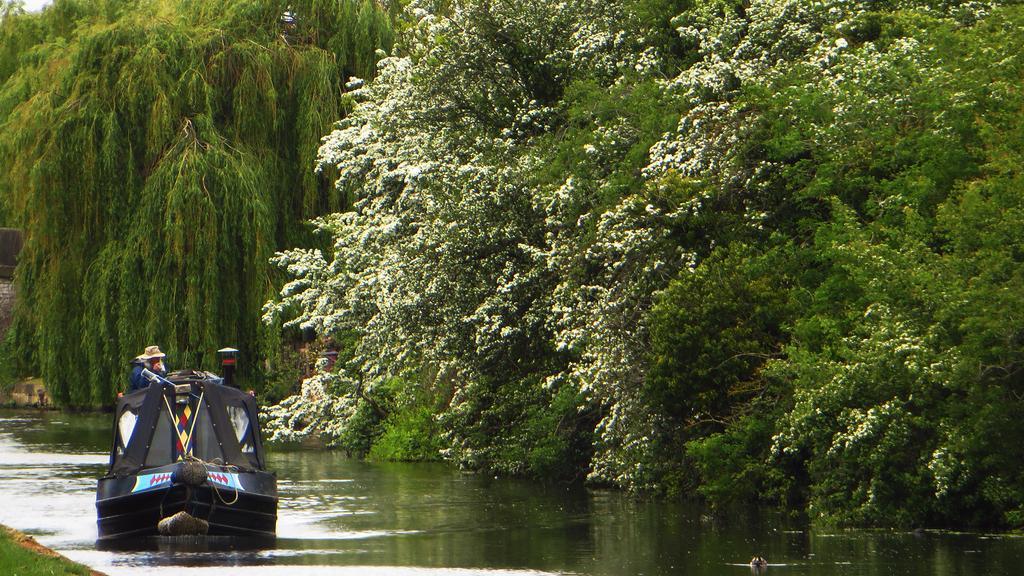Describe this image in one or two sentences. In this image I see number of trees and I see the green grass over here and I see the black boat on which there is a person and I see the water. 